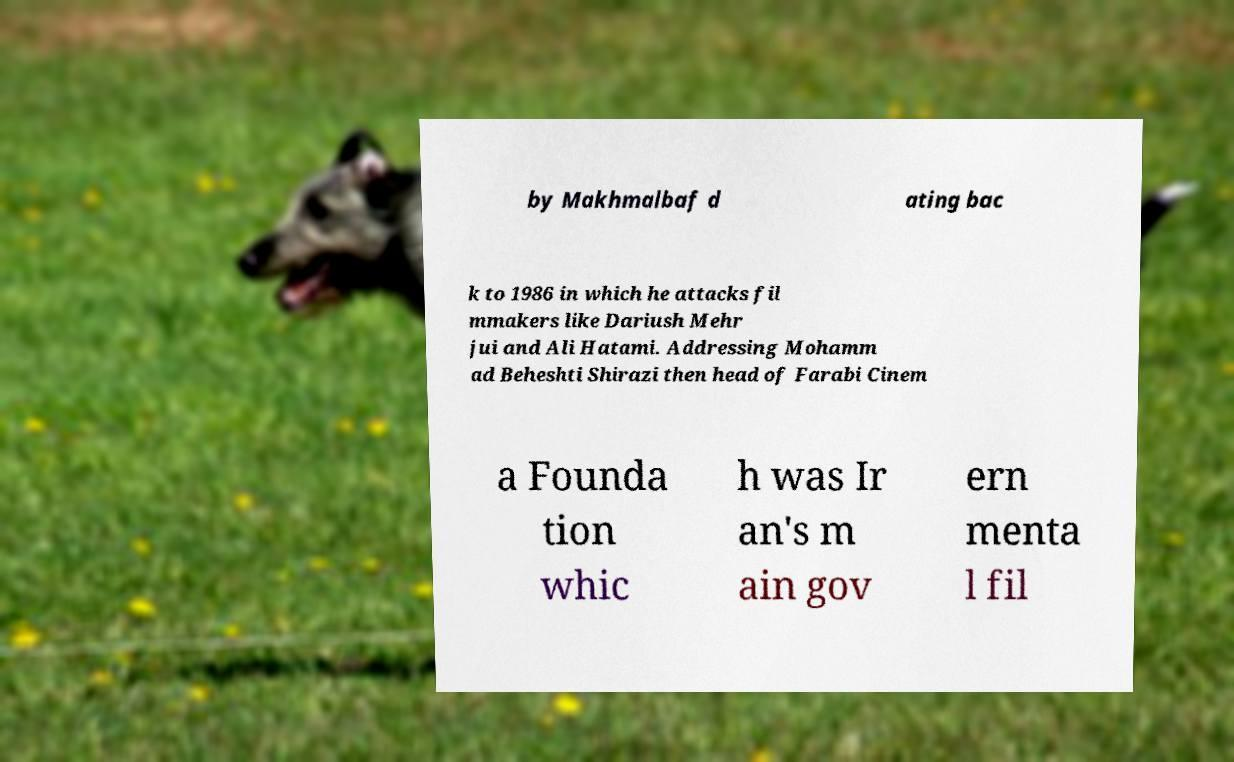Can you read and provide the text displayed in the image?This photo seems to have some interesting text. Can you extract and type it out for me? by Makhmalbaf d ating bac k to 1986 in which he attacks fil mmakers like Dariush Mehr jui and Ali Hatami. Addressing Mohamm ad Beheshti Shirazi then head of Farabi Cinem a Founda tion whic h was Ir an's m ain gov ern menta l fil 